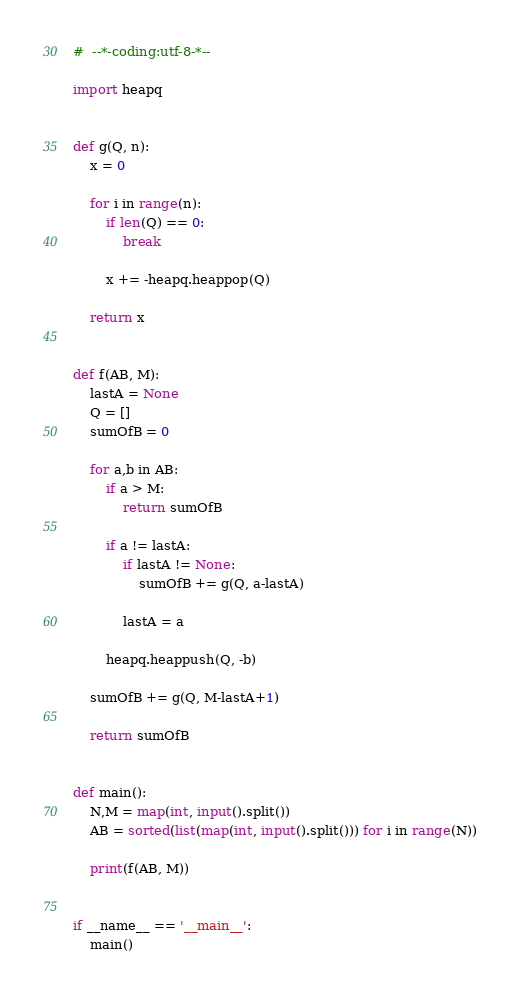<code> <loc_0><loc_0><loc_500><loc_500><_Python_>#  --*-coding:utf-8-*--

import heapq


def g(Q, n):
    x = 0

    for i in range(n):
        if len(Q) == 0:
            break

        x += -heapq.heappop(Q)

    return x


def f(AB, M):
    lastA = None
    Q = []
    sumOfB = 0

    for a,b in AB:
        if a > M:
            return sumOfB

        if a != lastA:
            if lastA != None:
                sumOfB += g(Q, a-lastA)

            lastA = a

        heapq.heappush(Q, -b)
            
    sumOfB += g(Q, M-lastA+1)

    return sumOfB


def main():
    N,M = map(int, input().split())
    AB = sorted(list(map(int, input().split())) for i in range(N))

    print(f(AB, M))


if __name__ == '__main__':
    main()
</code> 